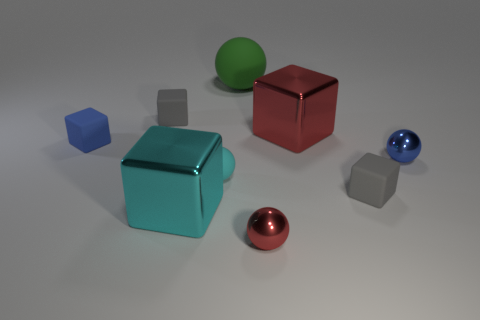What number of green things are the same material as the tiny blue cube?
Provide a succinct answer. 1. How many tiny gray balls are there?
Ensure brevity in your answer.  0. Does the blue metal ball have the same size as the gray rubber thing to the left of the cyan cube?
Provide a short and direct response. Yes. The thing that is behind the tiny gray block that is on the left side of the cyan shiny block is made of what material?
Ensure brevity in your answer.  Rubber. How big is the gray rubber object on the left side of the small cube that is right of the small gray object left of the tiny red metal sphere?
Provide a succinct answer. Small. There is a blue rubber object; is its shape the same as the rubber thing that is to the right of the green object?
Offer a very short reply. Yes. What is the tiny red sphere made of?
Offer a terse response. Metal. What number of rubber objects are tiny gray objects or blue cubes?
Offer a very short reply. 3. Are there fewer small blue matte things that are on the right side of the small blue rubber thing than cubes behind the big cyan metallic object?
Provide a succinct answer. Yes. Are there any red objects on the left side of the large shiny object on the left side of the ball behind the big red object?
Provide a short and direct response. No. 